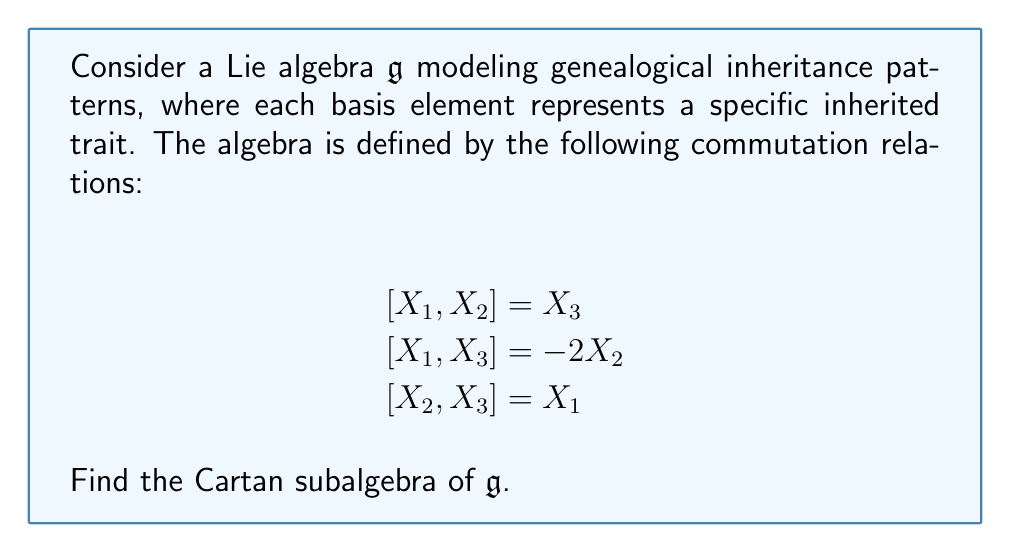Can you answer this question? To find the Cartan subalgebra of the given Lie algebra $\mathfrak{g}$, we need to follow these steps:

1) Recall that a Cartan subalgebra is a maximal abelian subalgebra consisting of semisimple elements.

2) In this case, we're dealing with a 3-dimensional Lie algebra. The structure constants can be read from the given commutation relations.

3) To find semisimple elements, we need to look for elements $H = aX_1 + bX_2 + cX_3$ such that $ad_H$ (the adjoint representation of $H$) has a diagonal matrix representation.

4) Let's compute $ad_H$ for a general element $H = aX_1 + bX_2 + cX_3$:

   $$ad_H(X_1) = [H, X_1] = b[X_2, X_1] + c[X_3, X_1] = -bX_3 + 2cX_2$$
   $$ad_H(X_2) = [H, X_2] = a[X_1, X_2] + c[X_3, X_2] = aX_3 - cX_1$$
   $$ad_H(X_3) = [H, X_3] = a[X_1, X_3] + b[X_2, X_3] = -2aX_2 + bX_1$$

5) The matrix representation of $ad_H$ in the basis $\{X_1, X_2, X_3\}$ is:

   $$ad_H = \begin{pmatrix}
   0 & -c & b \\
   2c & 0 & -2a \\
   -b & a & 0
   \end{pmatrix}$$

6) For $H$ to be semisimple, this matrix should be diagonalizable. The characteristic polynomial is:

   $$p(\lambda) = -\lambda^3 - (a^2 + b^2 + c^2)\lambda$$

7) For the matrix to be diagonal, we must have $a = b = c = 0$. This means that the only semisimple element is the zero element.

8) Therefore, the Cartan subalgebra is the zero subalgebra $\{0\}$.

This result is consistent with the fact that this Lie algebra is isomorphic to $\mathfrak{so}(3)$, the Lie algebra of 3D rotations, which has a zero Cartan subalgebra.
Answer: The Cartan subalgebra of the given Lie algebra $\mathfrak{g}$ is $\{0\}$, the zero subalgebra. 